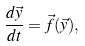Convert formula to latex. <formula><loc_0><loc_0><loc_500><loc_500>\frac { d \vec { y } } { d t } = \vec { f } ( \vec { y } ) ,</formula> 